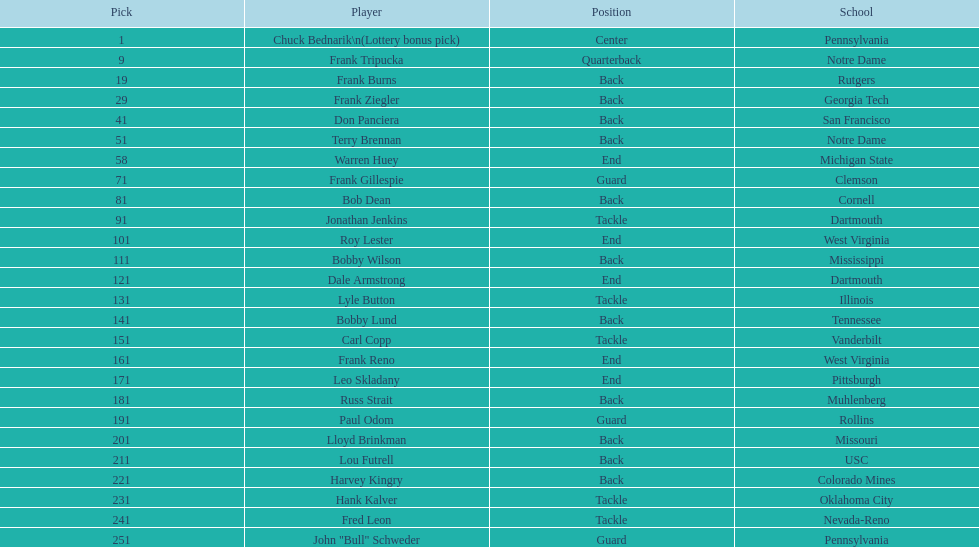Most prevalent school Pennsylvania. Would you mind parsing the complete table? {'header': ['Pick', 'Player', 'Position', 'School'], 'rows': [['1', 'Chuck Bednarik\\n(Lottery bonus pick)', 'Center', 'Pennsylvania'], ['9', 'Frank Tripucka', 'Quarterback', 'Notre Dame'], ['19', 'Frank Burns', 'Back', 'Rutgers'], ['29', 'Frank Ziegler', 'Back', 'Georgia Tech'], ['41', 'Don Panciera', 'Back', 'San Francisco'], ['51', 'Terry Brennan', 'Back', 'Notre Dame'], ['58', 'Warren Huey', 'End', 'Michigan State'], ['71', 'Frank Gillespie', 'Guard', 'Clemson'], ['81', 'Bob Dean', 'Back', 'Cornell'], ['91', 'Jonathan Jenkins', 'Tackle', 'Dartmouth'], ['101', 'Roy Lester', 'End', 'West Virginia'], ['111', 'Bobby Wilson', 'Back', 'Mississippi'], ['121', 'Dale Armstrong', 'End', 'Dartmouth'], ['131', 'Lyle Button', 'Tackle', 'Illinois'], ['141', 'Bobby Lund', 'Back', 'Tennessee'], ['151', 'Carl Copp', 'Tackle', 'Vanderbilt'], ['161', 'Frank Reno', 'End', 'West Virginia'], ['171', 'Leo Skladany', 'End', 'Pittsburgh'], ['181', 'Russ Strait', 'Back', 'Muhlenberg'], ['191', 'Paul Odom', 'Guard', 'Rollins'], ['201', 'Lloyd Brinkman', 'Back', 'Missouri'], ['211', 'Lou Futrell', 'Back', 'USC'], ['221', 'Harvey Kingry', 'Back', 'Colorado Mines'], ['231', 'Hank Kalver', 'Tackle', 'Oklahoma City'], ['241', 'Fred Leon', 'Tackle', 'Nevada-Reno'], ['251', 'John "Bull" Schweder', 'Guard', 'Pennsylvania']]} 